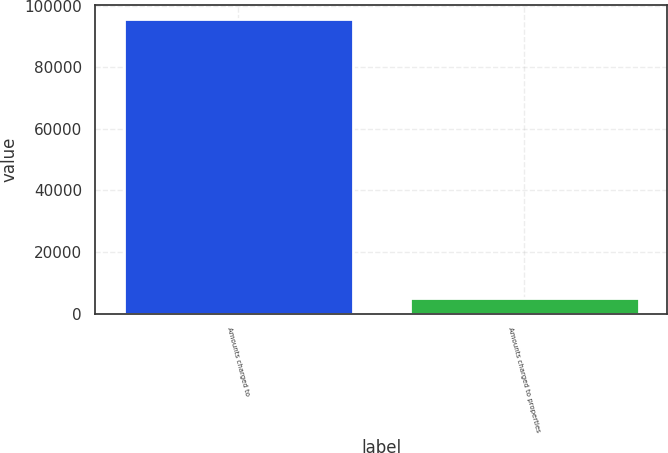Convert chart. <chart><loc_0><loc_0><loc_500><loc_500><bar_chart><fcel>Amounts charged to<fcel>Amounts charged to properties<nl><fcel>95564<fcel>5049<nl></chart> 